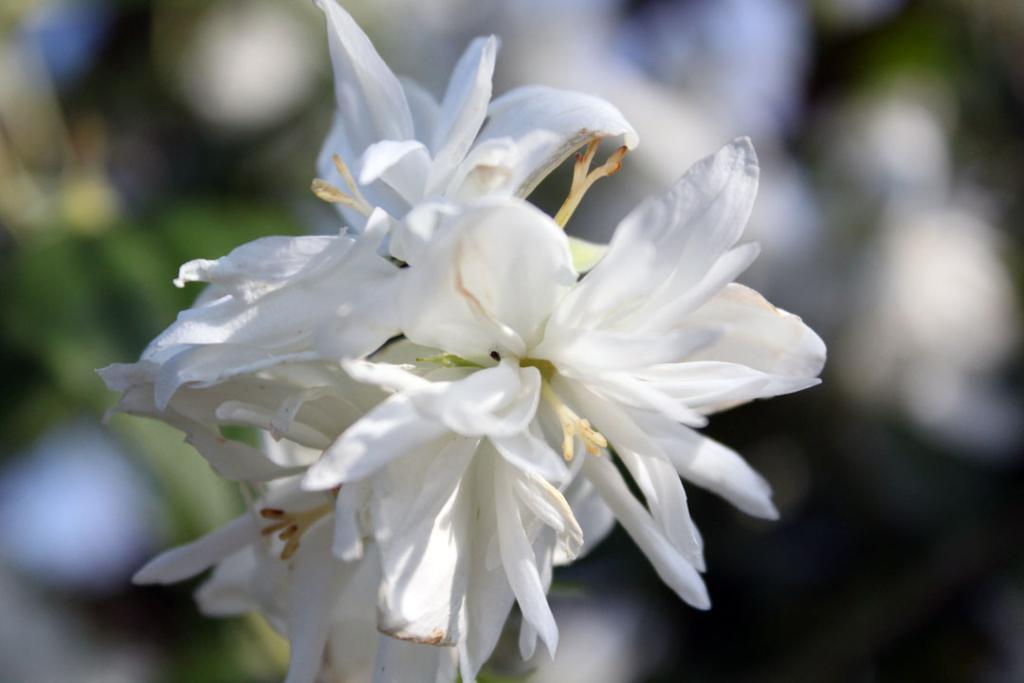Can you describe this image briefly? In this image, I can see a bunch of white flowers. There is a blurred background. 